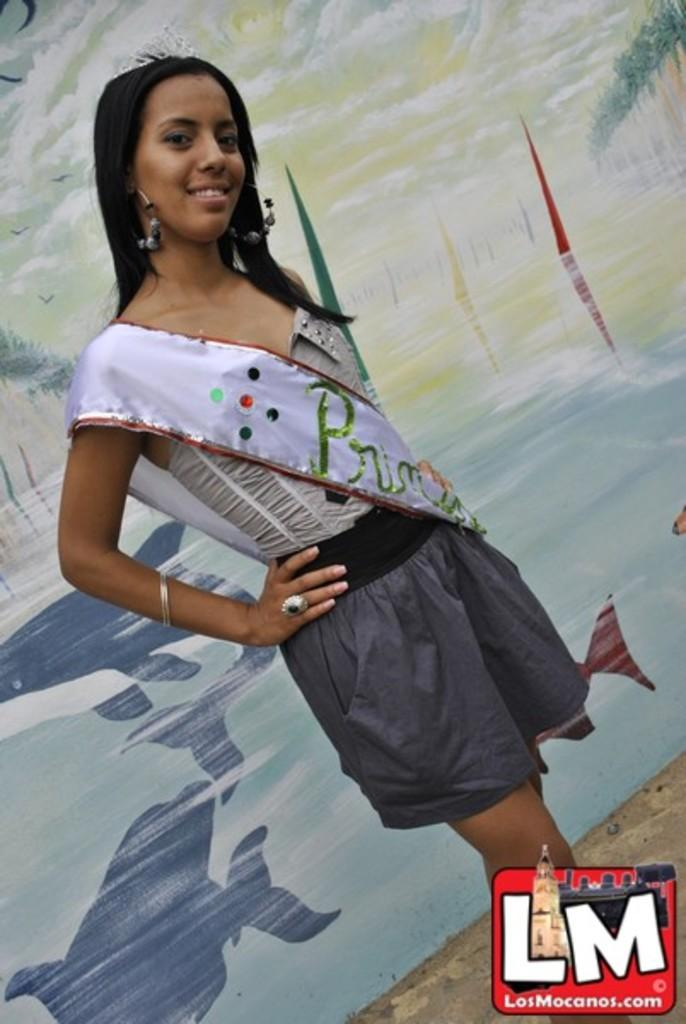What is the main subject of the image? There is a woman standing in the image. What is the woman standing on? The woman is standing on the ground. What is the woman wearing? The woman is wearing a dress. What additional accessory does the woman have? The woman has a cloth on her shoulder. What can be seen in the background of the image? There is a painting visible in the background of the image. How many ladybugs can be seen crawling on the woman's dress in the image? There are no ladybugs visible on the woman's dress in the image. What type of sand can be seen in the image? There is no sand present in the image. 